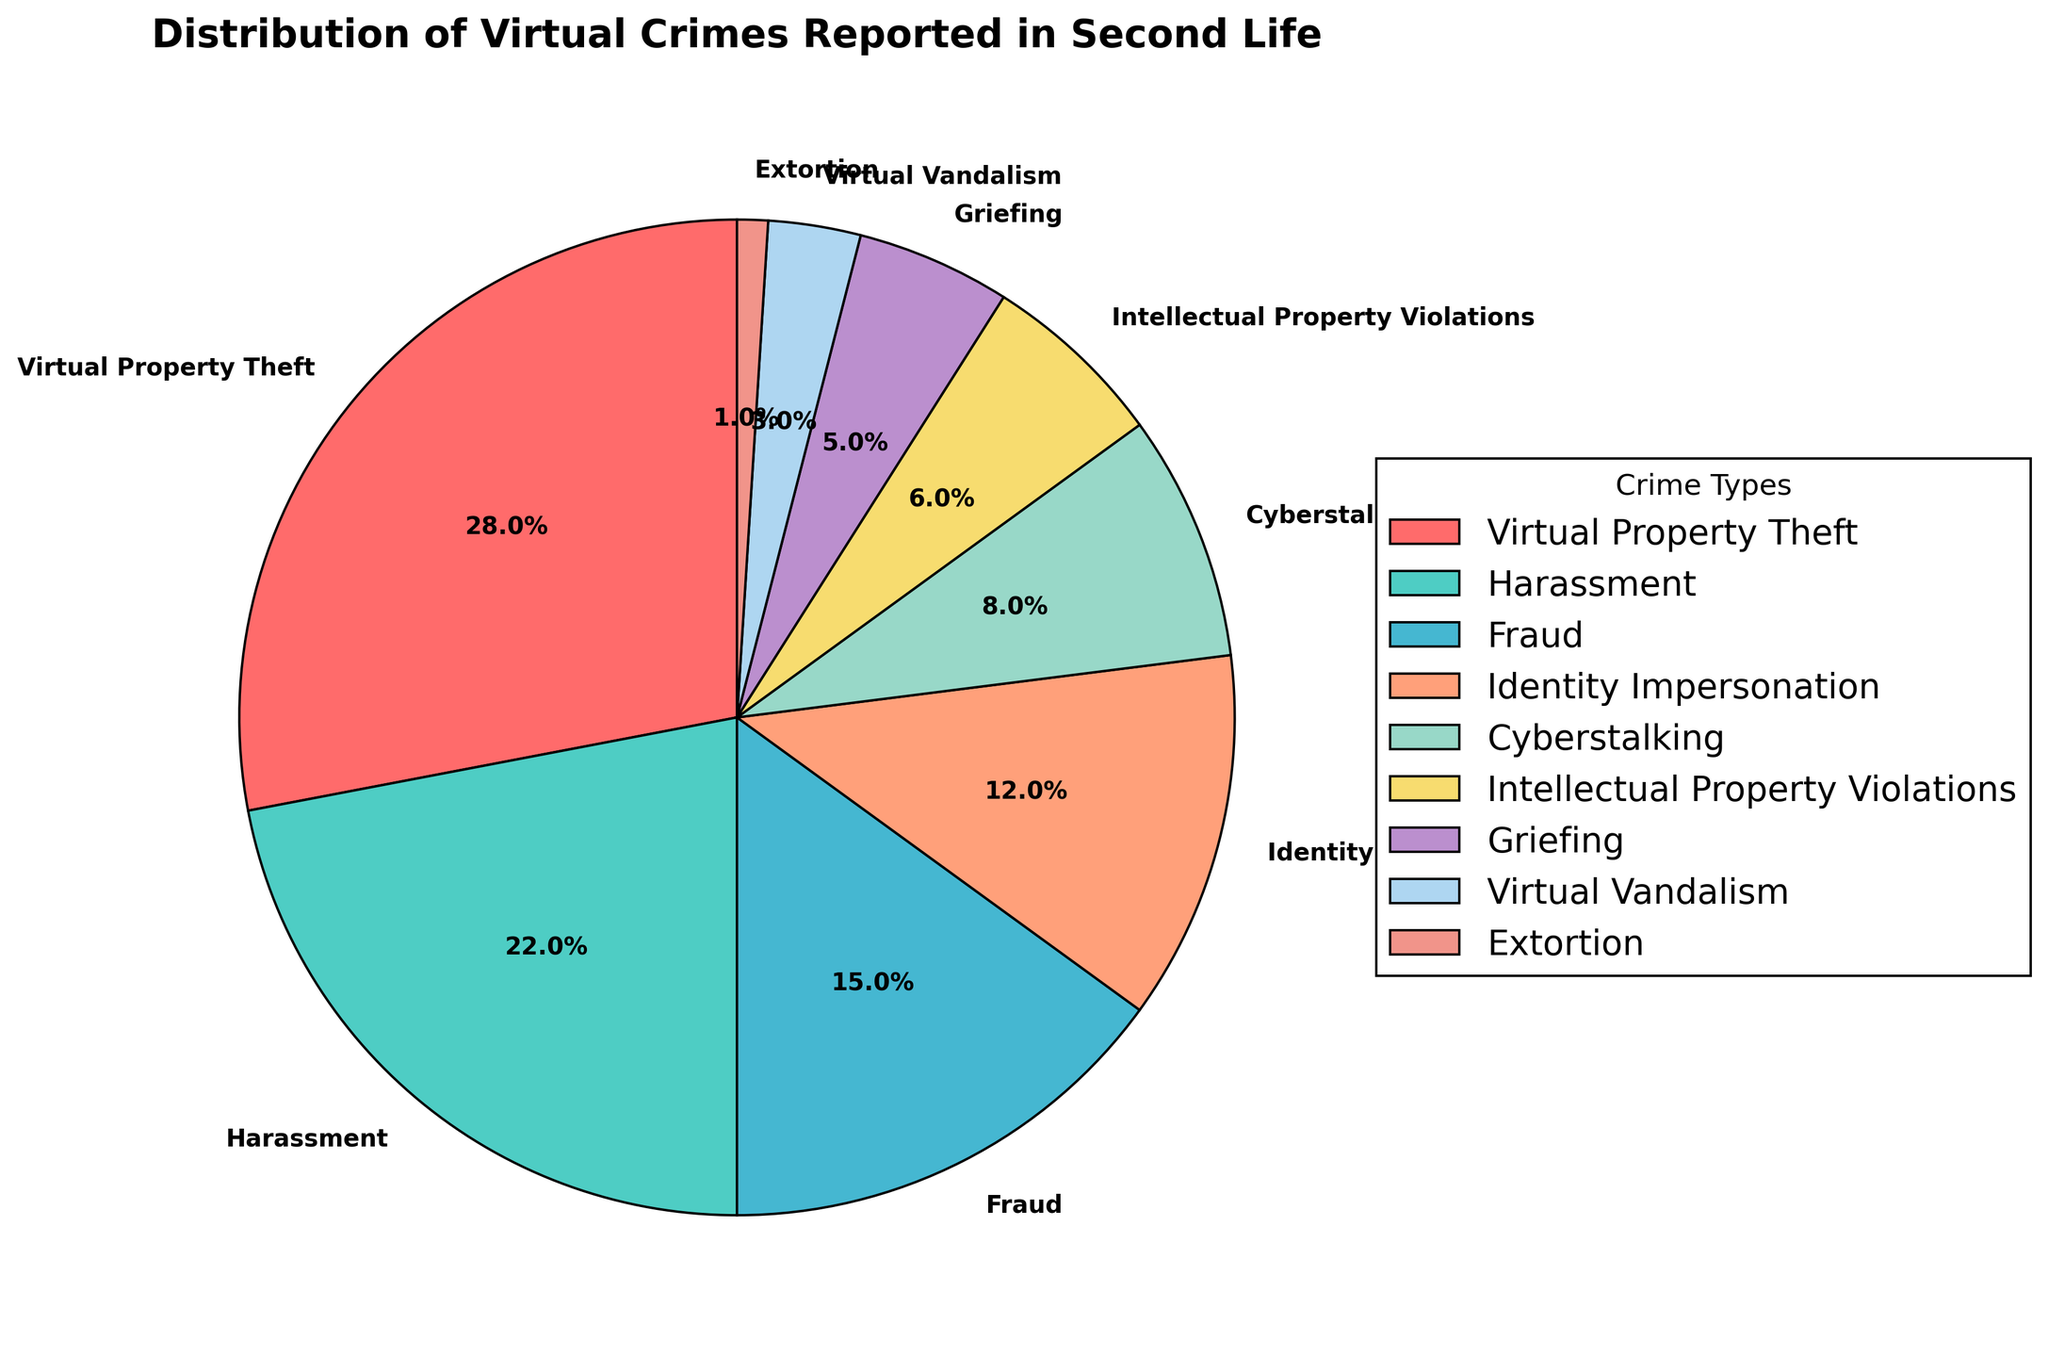What's the most common type of virtual crime reported in Second Life? Look at the crime with the highest percentage in the pie chart. The one with the largest wedge is the most common.
Answer: Virtual Property Theft Which two crimes have the closest percentage? Compare the percentages of each crime and find the pairs that have the smallest difference.
Answer: Harassment and Virtual Property Theft How much more common is Virtual Property Theft compared to Extortion? Subtract the percentage of Extortion from Virtual Property Theft.
Answer: 27% Which crimes together make up half of the reported virtual crimes? Add the percentages of the largest crimes until you reach or exceed 50%.
Answer: Virtual Property Theft and Harassment What percentage of crimes are related to identity? Look for Identity Impersonation percentage.
Answer: 12% Which type of crime is least reported? Identify the crime with the smallest wedge and percentage.
Answer: Extortion How many crimes have a percentage below 10%? Count the number of wedges with percentages less than 10%.
Answer: 4 If you combine Cyberstalking and Griefing, what percentage do they make up? Add the percentages of Cyberstalking and Griefing.
Answer: 13% Which crime types use shades of blue in the chart? Identify wedges colored blue and their corresponding crime types based on the legend.
Answer: Harassment and Intellectual Property Violations What is the difference between the highest and lowest reported crime percentages? Subtract the smallest percentage from the largest percentage observed in the chart.
Answer: 27% 